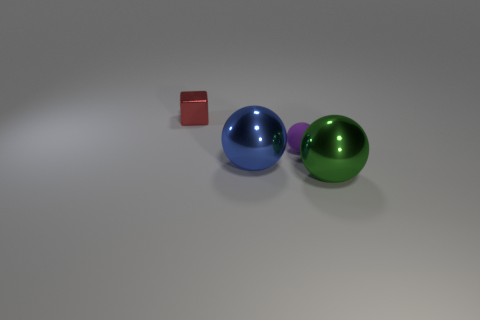Is there anything else that has the same material as the tiny red object?
Your answer should be very brief. Yes. What number of big blue spheres are behind the tiny red shiny object?
Make the answer very short. 0. Are there fewer metallic balls to the right of the green thing than green things that are right of the cube?
Ensure brevity in your answer.  Yes. How many cyan things are there?
Provide a succinct answer. 0. There is a small object in front of the red metal thing; what is its color?
Your response must be concise. Purple. The matte ball is what size?
Provide a succinct answer. Small. There is a cube; is its color the same as the small thing right of the block?
Offer a terse response. No. There is a large ball that is behind the object right of the tiny ball; what is its color?
Keep it short and to the point. Blue. Does the small object in front of the shiny cube have the same shape as the large green object?
Keep it short and to the point. Yes. What number of objects are both behind the tiny rubber sphere and right of the purple thing?
Your answer should be very brief. 0. 